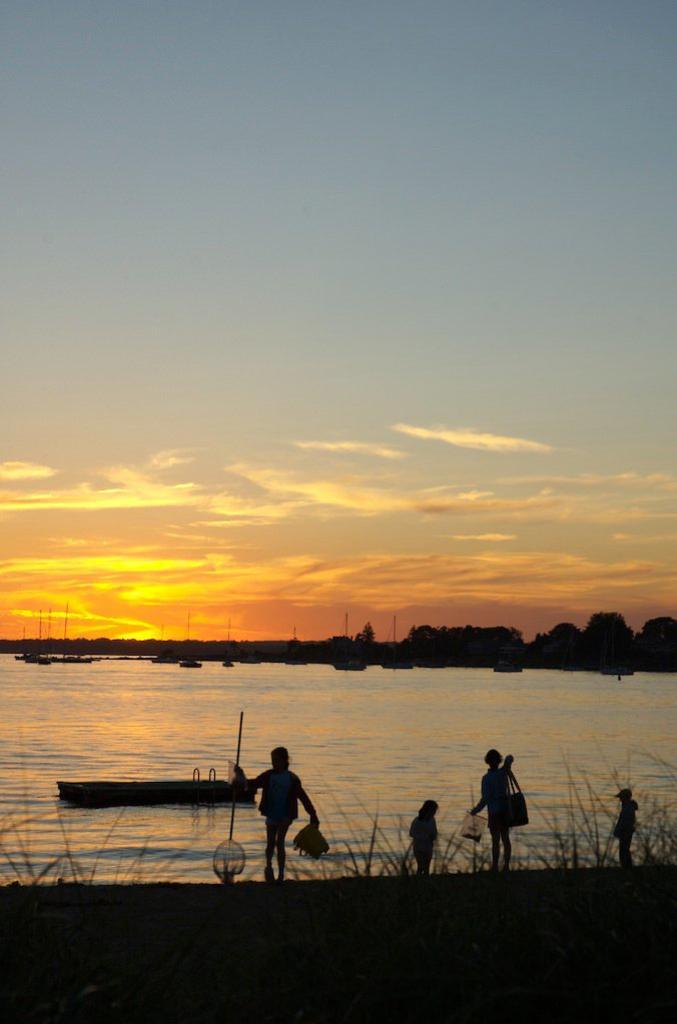Could you give a brief overview of what you see in this image? In this picture I can see there is a lake and there are some people standing here and there are some children and in the backdrop there are some trees and the sky is clear. 